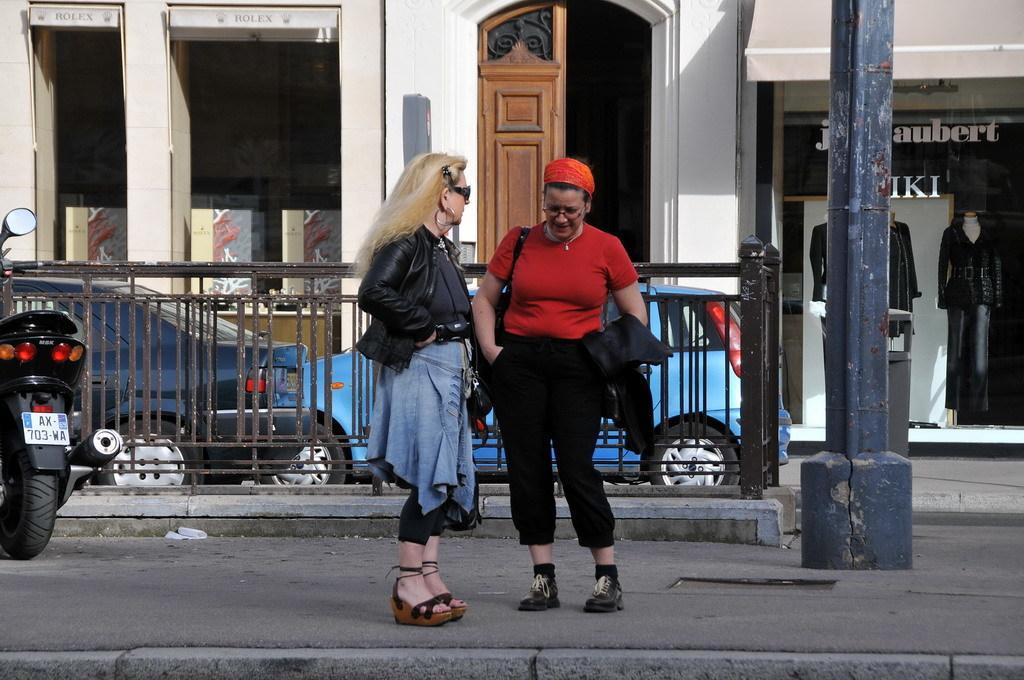Could you give a brief overview of what you see in this image? In this image there are few people standing on the road, behind them there is a fence, cars and buildings. 